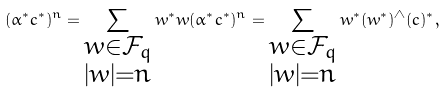Convert formula to latex. <formula><loc_0><loc_0><loc_500><loc_500>( \alpha ^ { * } c ^ { * } ) ^ { n } = \sum _ { \substack { w \in \mathcal { F } _ { q } \\ | w | = n } } w ^ { * } w ( \alpha ^ { * } c ^ { * } ) ^ { n } = \sum _ { \substack { w \in \mathcal { F } _ { q } \\ | w | = n } } w ^ { * } ( w ^ { * } ) ^ { \wedge } ( c ) ^ { * } ,</formula> 